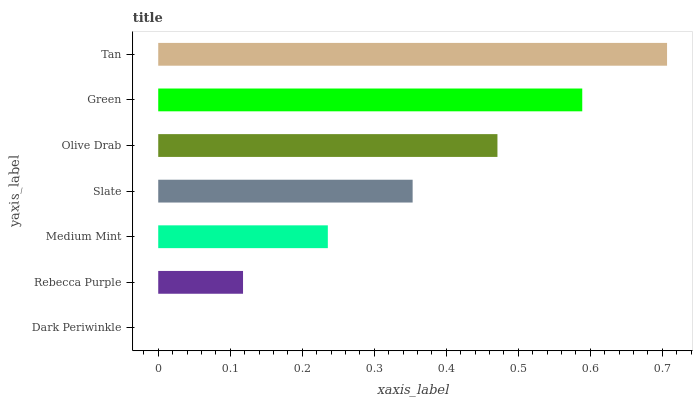Is Dark Periwinkle the minimum?
Answer yes or no. Yes. Is Tan the maximum?
Answer yes or no. Yes. Is Rebecca Purple the minimum?
Answer yes or no. No. Is Rebecca Purple the maximum?
Answer yes or no. No. Is Rebecca Purple greater than Dark Periwinkle?
Answer yes or no. Yes. Is Dark Periwinkle less than Rebecca Purple?
Answer yes or no. Yes. Is Dark Periwinkle greater than Rebecca Purple?
Answer yes or no. No. Is Rebecca Purple less than Dark Periwinkle?
Answer yes or no. No. Is Slate the high median?
Answer yes or no. Yes. Is Slate the low median?
Answer yes or no. Yes. Is Medium Mint the high median?
Answer yes or no. No. Is Tan the low median?
Answer yes or no. No. 